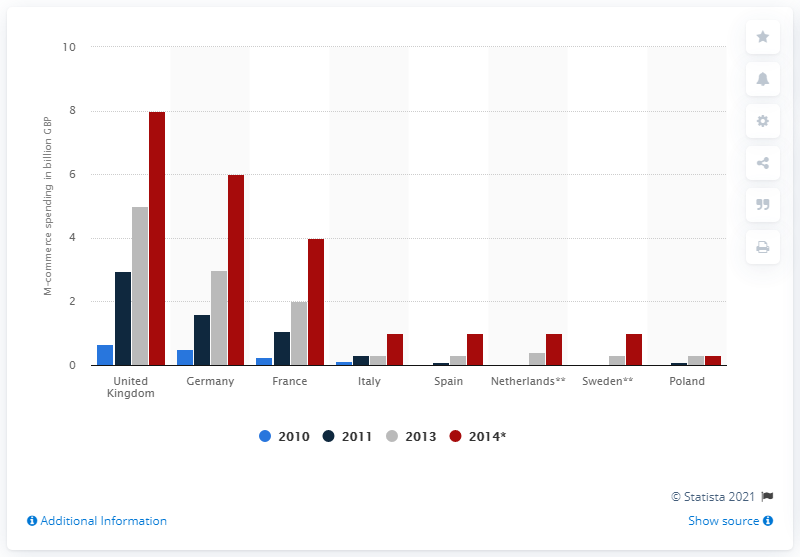Mention a couple of crucial points in this snapshot. In 2011, the amount of mobile commerce spending in the UK was 2.97. The expected m-commerce spending in the UK in 2014 was approximately 8... 